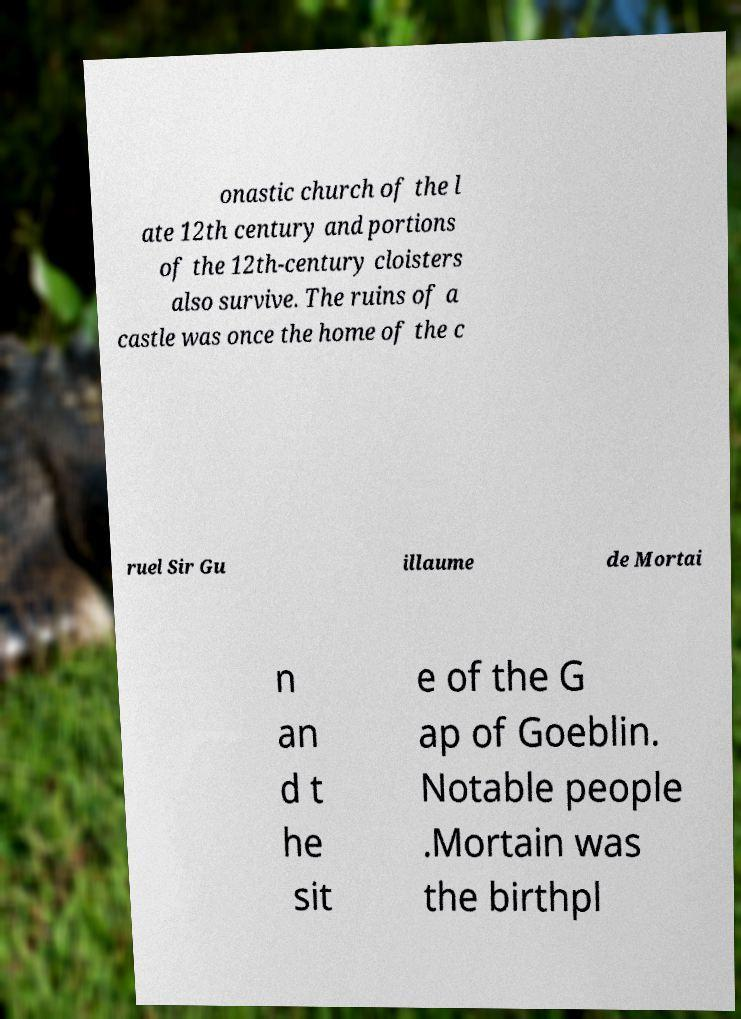For documentation purposes, I need the text within this image transcribed. Could you provide that? onastic church of the l ate 12th century and portions of the 12th-century cloisters also survive. The ruins of a castle was once the home of the c ruel Sir Gu illaume de Mortai n an d t he sit e of the G ap of Goeblin. Notable people .Mortain was the birthpl 